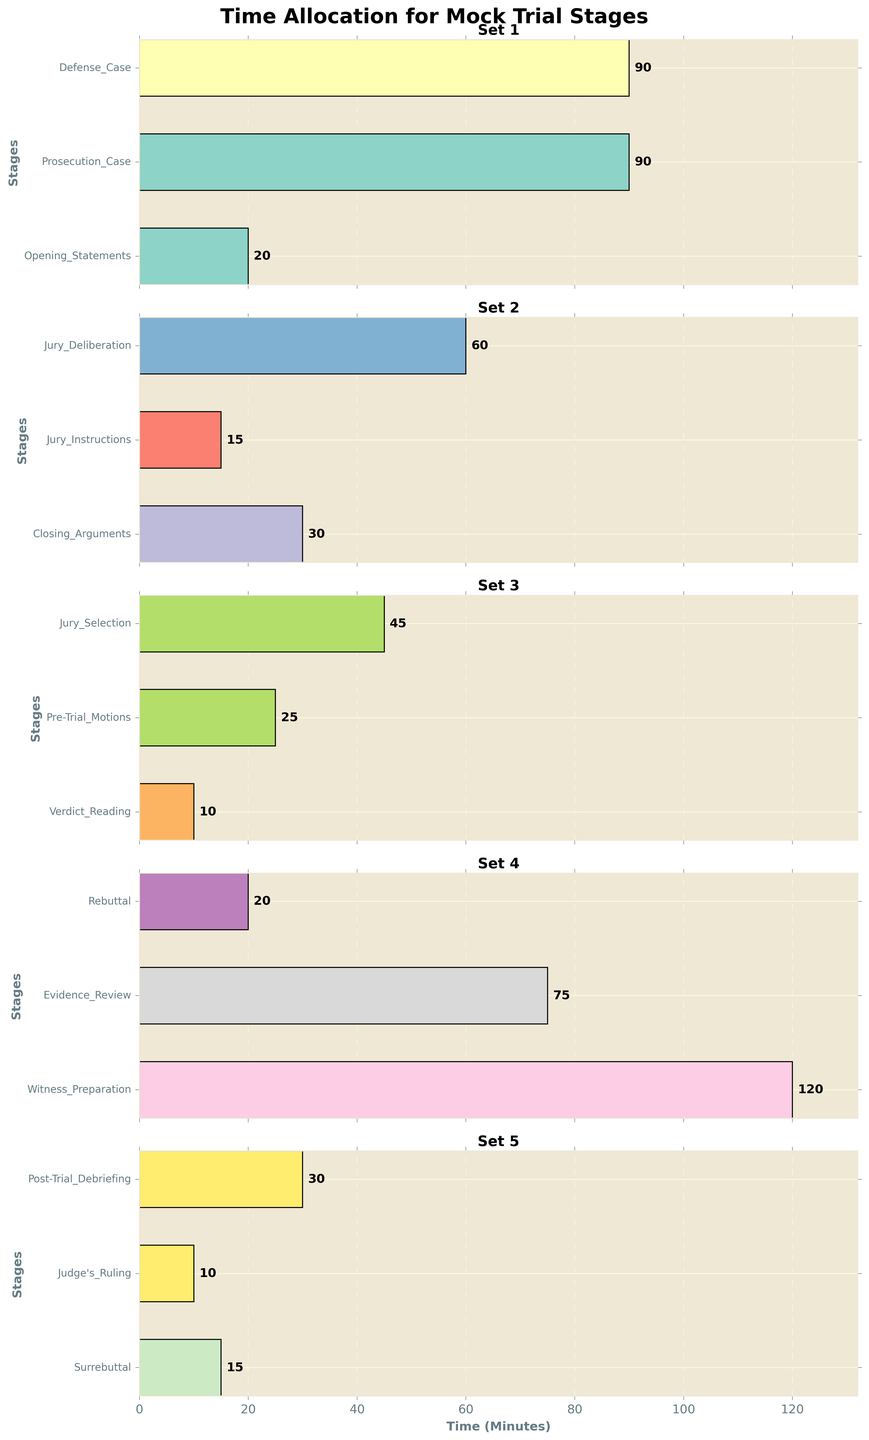What is the total time allocated for the first set of stages? The first set includes Opening Statements, Prosecution Case, and Defense Case. The times allocated are 20, 90, and 90 minutes respectively. Adding these up gives 20 + 90 + 90 = 200 minutes.
Answer: 200 Is the time allocated to Prosecution Case more than the time allocated to Jury Deliberation and Closing Arguments combined? Prosecution Case is allocated 90 minutes. Jury Deliberation is 60 minutes and Closing Arguments is 30 minutes, together totaling 60 + 30 = 90 minutes. Hence, 90 is equal to 90.
Answer: No Which stage has the highest time allocation in the third set of stages? The third set of stages includes Jury Selection, Witness Preparation, and Evidence Review. The time allocations are 45, 120, and 75 minutes respectively. The highest among these is 120 minutes.
Answer: Witness Preparation What is the combined time for Rebuttal and Surrebuttal? Rebuttal is allocated 20 minutes and Surrebuttal is allocated 15 minutes. Combining these gives 20 + 15 = 35 minutes.
Answer: 35 Which set has the least time allocation and what is the total time for that set? By summing the times for each set:  
Set 1 (Opening Statements, Prosecution Case, Defense Case): 20 + 90 + 90 = 200  
Set 2 (Closing Arguments, Jury Instructions, Jury Deliberation): 30 + 15 + 60 = 105  
Set 3 (Verdict Reading, Pre-Trial Motions, Jury Selection): 10 + 25 + 45 = 80  
Set 4 (Witness Preparation, Evidence Review, Rebuttal): 120 + 75 + 20 = 215  
Set 5 (Surrebuttal, Judge's Ruling, Post-Trial Debriefing): 15 + 10 + 30 = 55  
So the least time allocation set is Set 5 with 55 minutes.
Answer: Set 5, 55 What is the difference in time allocation between Witness Preparation and Defense Case? Witness Preparation is allocated 120 minutes while Defense Case is allocated 90 minutes. The difference is 120 - 90 = 30 minutes.
Answer: 30 Which two stages have equal time allocations and what are those times? Prosecution Case and Defense Case both have time allocations of 90 minutes each.
Answer: Prosecution Case and Defense Case, 90 minutes How does the length of the bar for Evidence Review compare visually to the length of the bar for Jury Instructions? The bar for Evidence Review is significantly longer than the bar for Jury Instructions, indicating that more time is allocated to Evidence Review (75 minutes) compared to Jury Instructions (15 minutes).
Answer: Longer What is the average time allocation for the second set of stages? The second set includes Closing Arguments, Jury Instructions, and Jury Deliberation. The times are 30, 15, and 60 minutes respectively. Their average is (30 + 15 + 60)/3 = 35 minutes.
Answer: 35 Which stage's bar is colored differently than the others in the first set? All bars in the first set (Opening Statements, Prosecution Case, Defense Case) have different colors as each bar in the sets uses a distinct color from the color palette.
Answer: None 